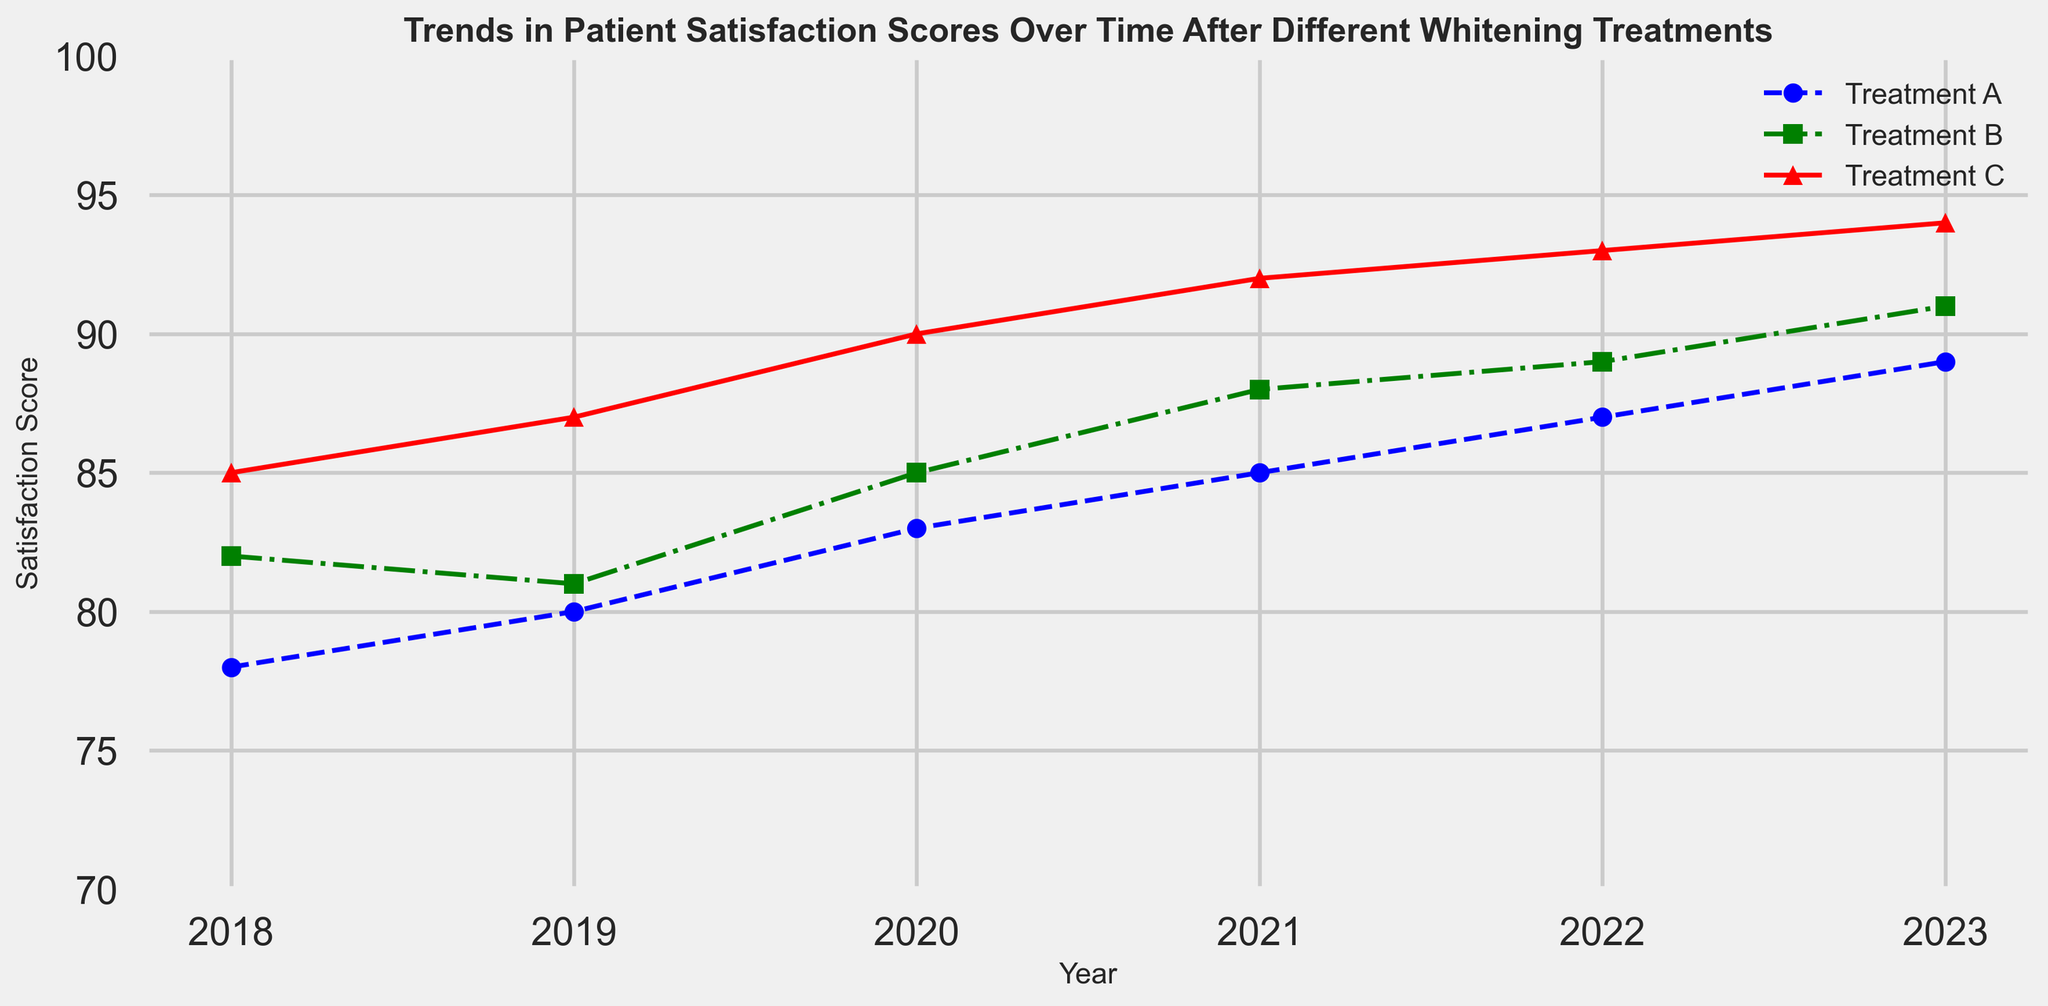Which treatment had the highest satisfaction score in 2023? Looking at the plot for the year 2023, Treatment C (red line) reaches the highest satisfaction score.
Answer: Treatment C Between which years did Treatment A see the greatest increase in satisfaction score? Compare the differences in satisfaction scores between consecutive years for Treatment A (blue line). The increase is greatest between 2020 and 2021 (2 points increase).
Answer: 2020-2021 On average, how much did Treatment B's satisfaction score increase per year from 2018 to 2023? Calculate the differences in satisfaction scores between each year for Treatment B (green line) and find the average increase. (81-82) + (85-81) + (88-85) + (89-88) + (91-89) = 1+4+3+1+2 = 11 over 5 years; 11/5 = 2.2.
Answer: 2.2 Which treatment showed the least improvement in satisfaction scores between 2018 and 2023? Calculate the total increase in satisfaction scores for each treatment and compare: Treatment A (89-78) = 11, Treatment B (91-82) = 9, Treatment C (94-85) = 9. Treatment B and C both show the least improvement with a 9-point increase.
Answer: Treatment B and C How did the satisfaction scores for Treatment C change from 2018 to 2020? Look at the satisfaction scores for Treatment C (red line) over the years 2018 to 2020: 85 -> 87 -> 90, which shows an increase of 3 points in two years.
Answer: Increased by 3 Which treatment had the largest variance in satisfaction scores between 2018 and 2023? Calculate the variance for the satisfaction scores of each treatment. Data points: Treatment A = [78, 80, 83, 85, 87, 89], Treatment B = [82, 81, 85, 88, 89, 91], Treatment C = [85, 87, 90, 92, 93, 94]. By observing the spread, Treatment A shows the largest variance.
Answer: Treatment A Are there any years where all treatments ended with the same satisfaction score? Check if there is a year where all lines (Treatment A, B, C) converge to the same point. No such convergence point exists between 2018 to 2023.
Answer: No What is the difference in satisfaction scores between Treatment A and Treatment B in 2022? Compare the points on the plot for Treatments A and B in 2022: Treatment A is at 87, and Treatment B is at 89. The difference is 89 - 87.
Answer: 2 